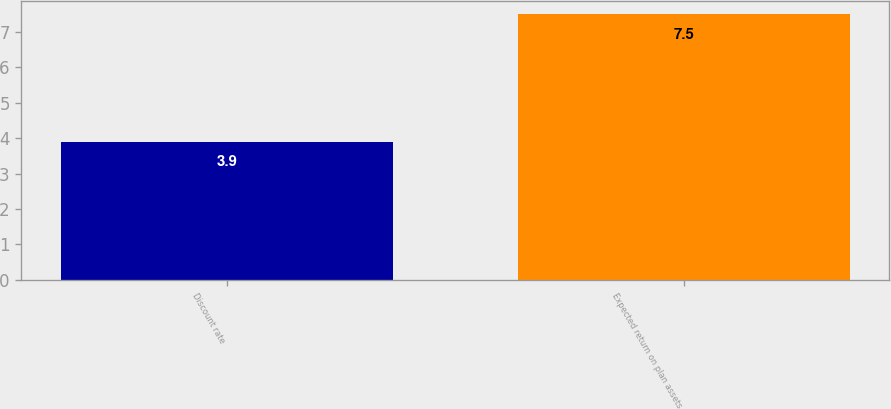Convert chart. <chart><loc_0><loc_0><loc_500><loc_500><bar_chart><fcel>Discount rate<fcel>Expected return on plan assets<nl><fcel>3.9<fcel>7.5<nl></chart> 